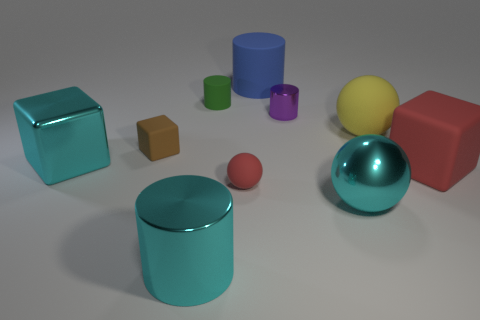Subtract all cylinders. How many objects are left? 6 Add 8 purple things. How many purple things are left? 9 Add 9 tiny brown cubes. How many tiny brown cubes exist? 10 Subtract 0 gray spheres. How many objects are left? 10 Subtract all large cyan metallic balls. Subtract all large metal cubes. How many objects are left? 8 